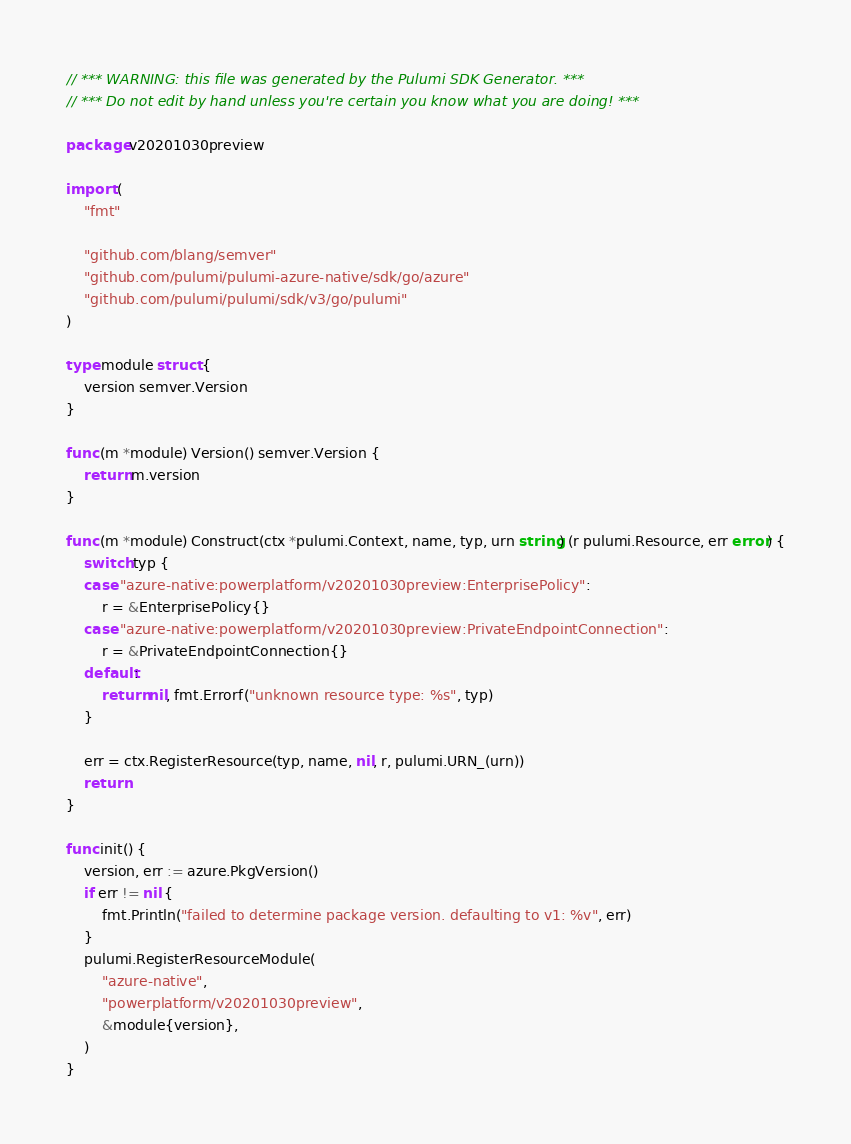<code> <loc_0><loc_0><loc_500><loc_500><_Go_>// *** WARNING: this file was generated by the Pulumi SDK Generator. ***
// *** Do not edit by hand unless you're certain you know what you are doing! ***

package v20201030preview

import (
	"fmt"

	"github.com/blang/semver"
	"github.com/pulumi/pulumi-azure-native/sdk/go/azure"
	"github.com/pulumi/pulumi/sdk/v3/go/pulumi"
)

type module struct {
	version semver.Version
}

func (m *module) Version() semver.Version {
	return m.version
}

func (m *module) Construct(ctx *pulumi.Context, name, typ, urn string) (r pulumi.Resource, err error) {
	switch typ {
	case "azure-native:powerplatform/v20201030preview:EnterprisePolicy":
		r = &EnterprisePolicy{}
	case "azure-native:powerplatform/v20201030preview:PrivateEndpointConnection":
		r = &PrivateEndpointConnection{}
	default:
		return nil, fmt.Errorf("unknown resource type: %s", typ)
	}

	err = ctx.RegisterResource(typ, name, nil, r, pulumi.URN_(urn))
	return
}

func init() {
	version, err := azure.PkgVersion()
	if err != nil {
		fmt.Println("failed to determine package version. defaulting to v1: %v", err)
	}
	pulumi.RegisterResourceModule(
		"azure-native",
		"powerplatform/v20201030preview",
		&module{version},
	)
}
</code> 